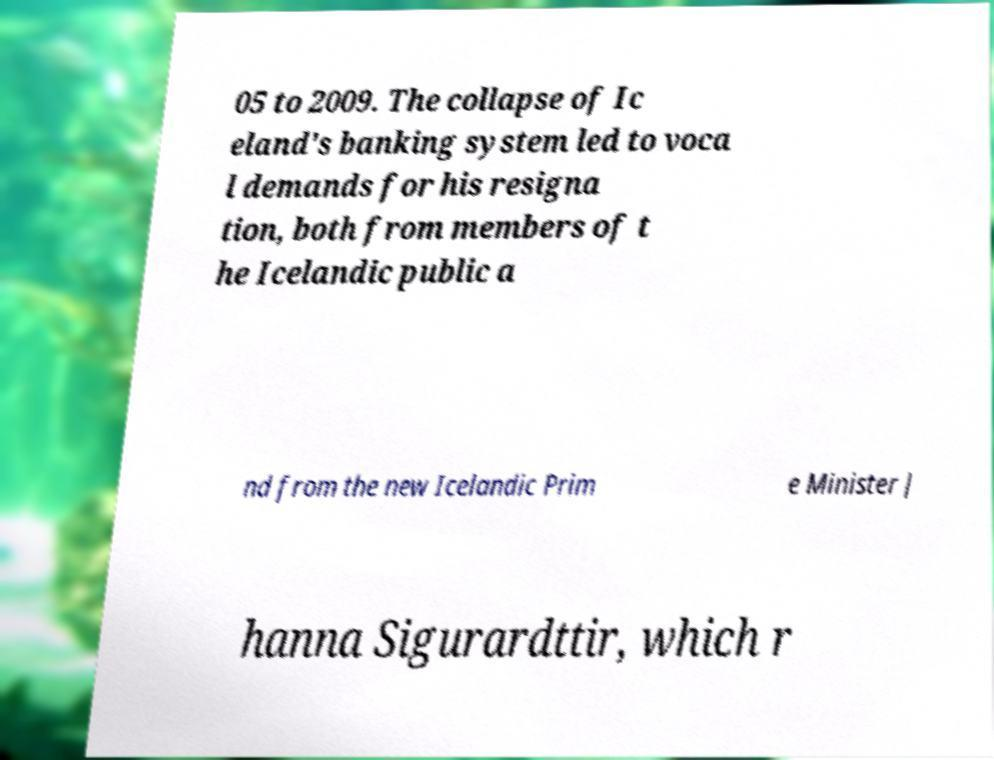Please identify and transcribe the text found in this image. 05 to 2009. The collapse of Ic eland's banking system led to voca l demands for his resigna tion, both from members of t he Icelandic public a nd from the new Icelandic Prim e Minister J hanna Sigurardttir, which r 